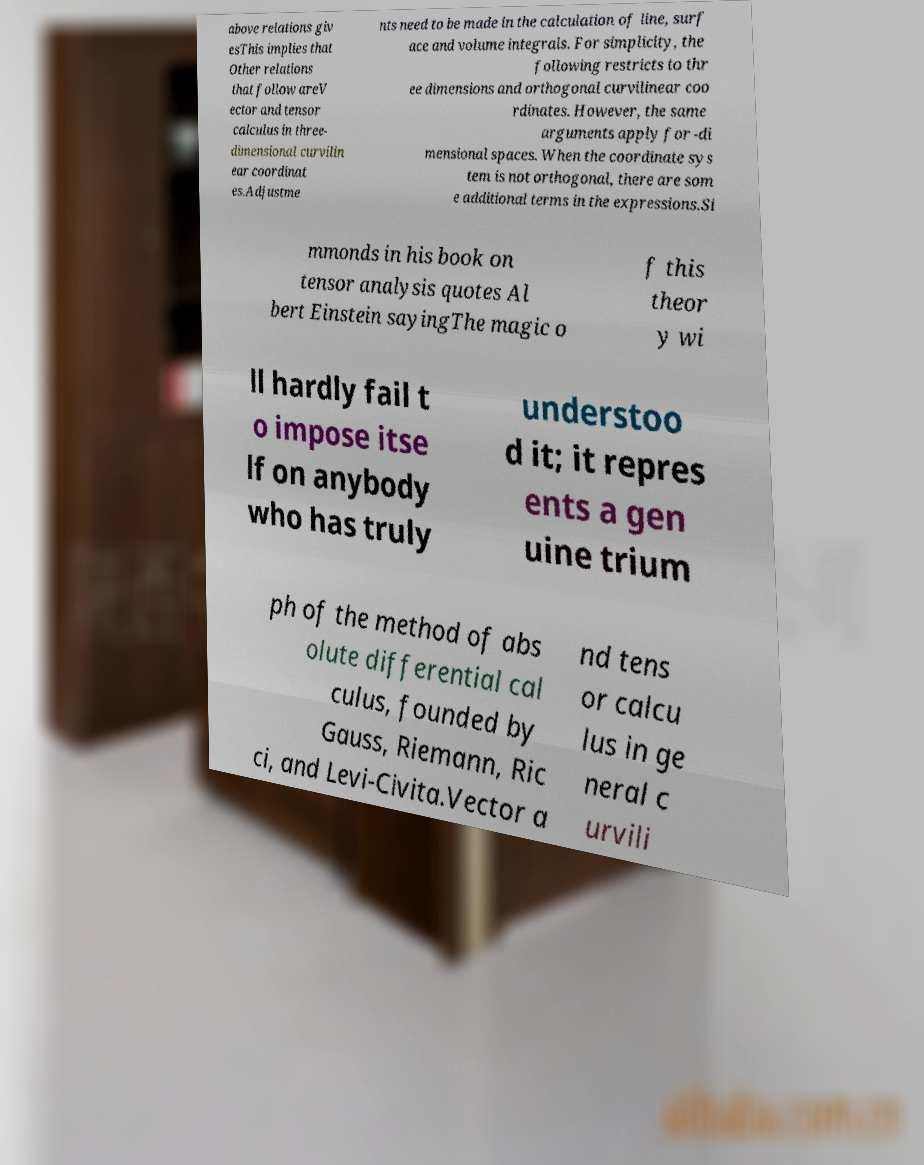What messages or text are displayed in this image? I need them in a readable, typed format. above relations giv esThis implies that Other relations that follow areV ector and tensor calculus in three- dimensional curvilin ear coordinat es.Adjustme nts need to be made in the calculation of line, surf ace and volume integrals. For simplicity, the following restricts to thr ee dimensions and orthogonal curvilinear coo rdinates. However, the same arguments apply for -di mensional spaces. When the coordinate sys tem is not orthogonal, there are som e additional terms in the expressions.Si mmonds in his book on tensor analysis quotes Al bert Einstein sayingThe magic o f this theor y wi ll hardly fail t o impose itse lf on anybody who has truly understoo d it; it repres ents a gen uine trium ph of the method of abs olute differential cal culus, founded by Gauss, Riemann, Ric ci, and Levi-Civita.Vector a nd tens or calcu lus in ge neral c urvili 